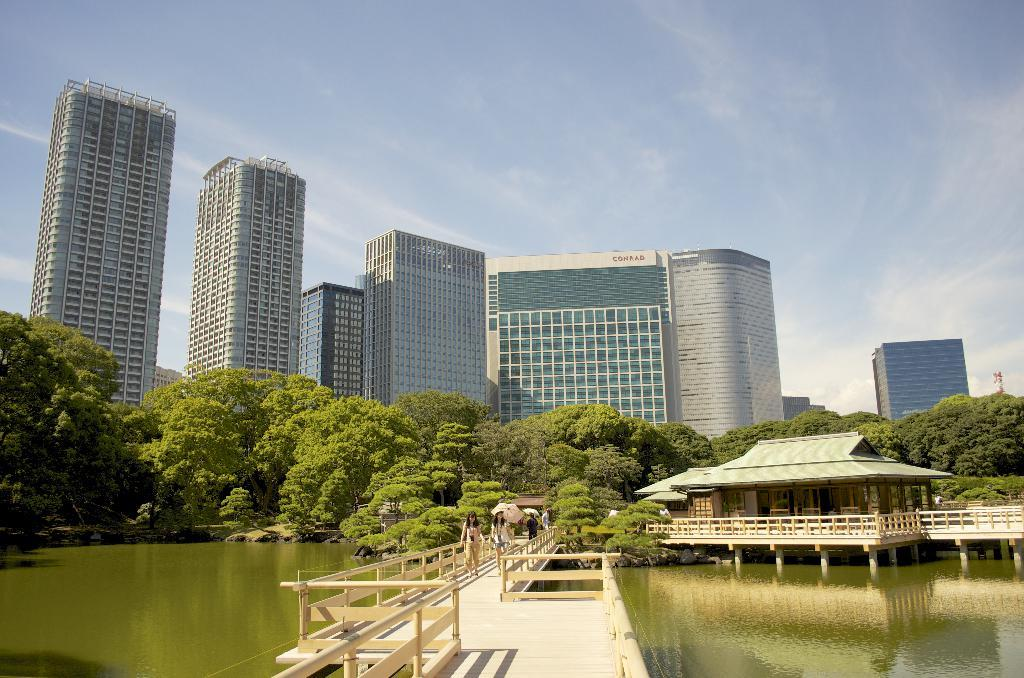What is the main structure in the middle of the image? There is a bridge in the middle of the image. What are the people on the bridge doing? There are people walking on the bridge. What can be seen below the bridge? There is water visible in the image. What type of man-made structures can be seen in the image? There are buildings in the image. What type of natural elements can be seen in the image? There are trees in the image. What is visible at the top of the image? The sky is visible at the top of the image. What type of pail is being used to collect salt in the image? There is no pail or salt present in the image. What sense is being used by the people walking on the bridge? The question is unclear and cannot be definitively answered based on the provided facts. However, it can be assumed that the people walking on the bridge are using their sense of sight, touch, and balance. 